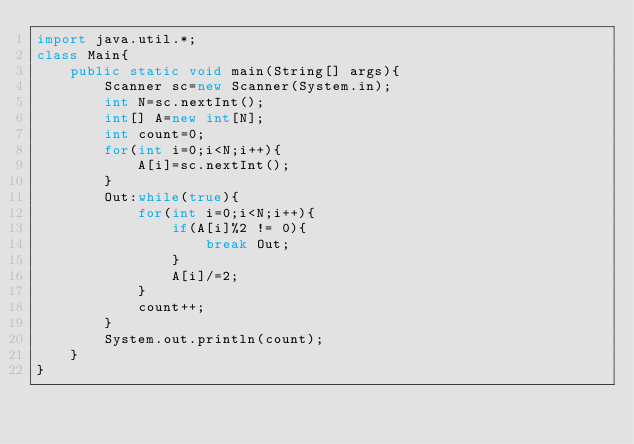<code> <loc_0><loc_0><loc_500><loc_500><_Java_>import java.util.*;
class Main{
	public static void main(String[] args){
		Scanner sc=new Scanner(System.in);
		int N=sc.nextInt();
		int[] A=new int[N];
		int count=0;
		for(int i=0;i<N;i++){
			A[i]=sc.nextInt();
		}
		Out:while(true){
			for(int i=0;i<N;i++){
				if(A[i]%2 != 0){
					break Out;
				}
				A[i]/=2;
			}
			count++;
		}
		System.out.println(count);
	}
}</code> 